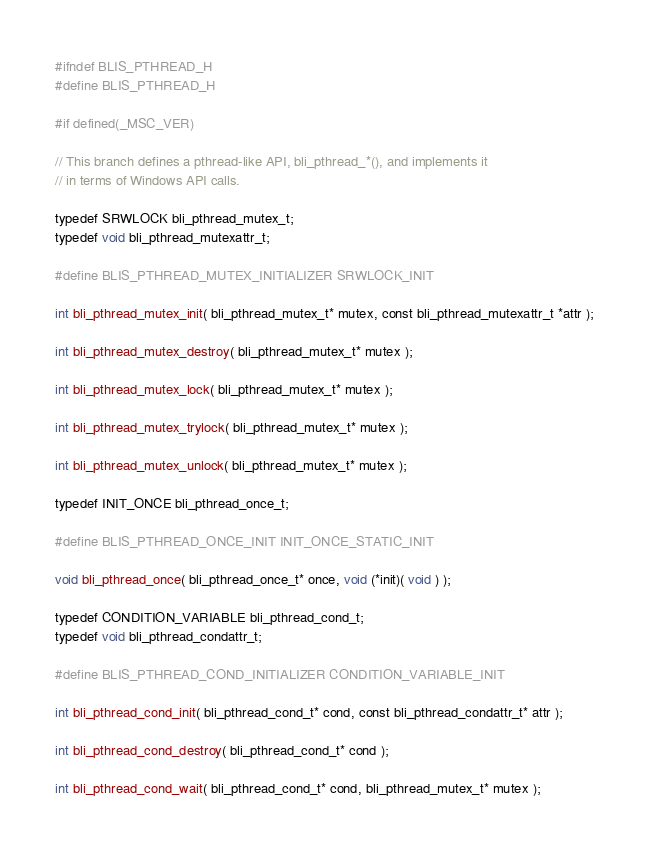Convert code to text. <code><loc_0><loc_0><loc_500><loc_500><_C_>#ifndef BLIS_PTHREAD_H
#define BLIS_PTHREAD_H

#if defined(_MSC_VER)

// This branch defines a pthread-like API, bli_pthread_*(), and implements it
// in terms of Windows API calls.

typedef SRWLOCK bli_pthread_mutex_t;
typedef void bli_pthread_mutexattr_t;

#define BLIS_PTHREAD_MUTEX_INITIALIZER SRWLOCK_INIT

int bli_pthread_mutex_init( bli_pthread_mutex_t* mutex, const bli_pthread_mutexattr_t *attr );

int bli_pthread_mutex_destroy( bli_pthread_mutex_t* mutex );

int bli_pthread_mutex_lock( bli_pthread_mutex_t* mutex );

int bli_pthread_mutex_trylock( bli_pthread_mutex_t* mutex );

int bli_pthread_mutex_unlock( bli_pthread_mutex_t* mutex );

typedef INIT_ONCE bli_pthread_once_t;

#define BLIS_PTHREAD_ONCE_INIT INIT_ONCE_STATIC_INIT

void bli_pthread_once( bli_pthread_once_t* once, void (*init)( void ) );

typedef CONDITION_VARIABLE bli_pthread_cond_t;
typedef void bli_pthread_condattr_t;

#define BLIS_PTHREAD_COND_INITIALIZER CONDITION_VARIABLE_INIT

int bli_pthread_cond_init( bli_pthread_cond_t* cond, const bli_pthread_condattr_t* attr );

int bli_pthread_cond_destroy( bli_pthread_cond_t* cond );

int bli_pthread_cond_wait( bli_pthread_cond_t* cond, bli_pthread_mutex_t* mutex );
</code> 